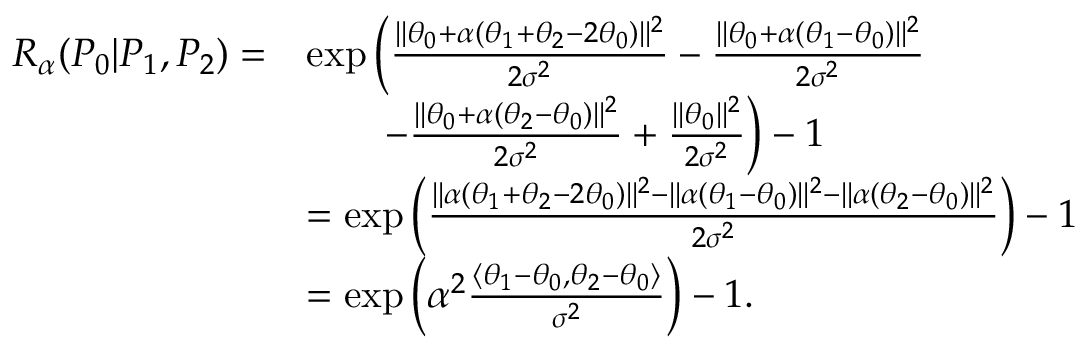Convert formula to latex. <formula><loc_0><loc_0><loc_500><loc_500>\begin{array} { r l } { { R _ { \alpha } } ( P _ { 0 } | P _ { 1 } , P _ { 2 } ) = } & { \exp \left ( \frac { \| \theta _ { 0 } + \alpha ( \theta _ { 1 } + \theta _ { 2 } - 2 \theta _ { 0 } ) \| ^ { 2 } } { 2 \sigma ^ { 2 } } - \frac { \| \theta _ { 0 } + \alpha ( \theta _ { 1 } - \theta _ { 0 } ) \| ^ { 2 } } { 2 \sigma ^ { 2 } } } \\ & { \quad - \frac { \| \theta _ { 0 } + \alpha ( \theta _ { 2 } - \theta _ { 0 } ) \| ^ { 2 } } { 2 \sigma ^ { 2 } } + \frac { \| \theta _ { 0 } \| ^ { 2 } } { 2 \sigma ^ { 2 } } \right ) - 1 } \\ & { = \exp \left ( \frac { \| \alpha ( \theta _ { 1 } + \theta _ { 2 } - 2 \theta _ { 0 } ) \| ^ { 2 } - \| \alpha ( \theta _ { 1 } - \theta _ { 0 } ) \| ^ { 2 } - \| \alpha ( \theta _ { 2 } - \theta _ { 0 } ) \| ^ { 2 } } { 2 \sigma ^ { 2 } } \right ) - 1 } \\ & { = \exp \left ( \alpha ^ { 2 } \frac { \langle \theta _ { 1 } - \theta _ { 0 } , \theta _ { 2 } - \theta _ { 0 } \rangle } { \sigma ^ { 2 } } \right ) - 1 . } \end{array}</formula> 